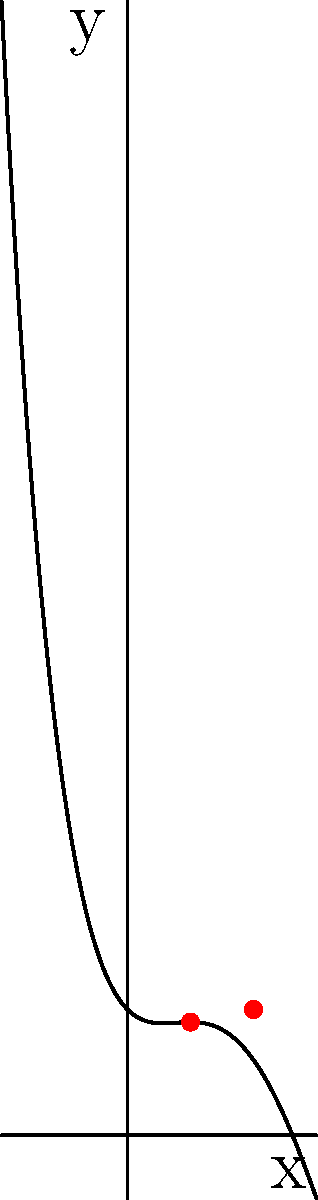The graph represents the audio wavelength of the theme song from a popular 80s variety show. If we model this wavelength as a polynomial function $f(x) = ax^4 + bx^3 + cx^2 + dx + e$, what is the degree of the polynomial, and how many local extrema does the function have in the visible interval? To answer this question, we need to analyze the graph:

1. Degree of the polynomial:
   - The graph appears to have one inflection point and changes direction multiple times.
   - The highest degree term dominates as x approaches infinity or negative infinity.
   - The curve seems to go up on both ends, indicating an even-degree polynomial.
   - Given the complexity of the curve, the degree is likely 4.

2. Local extrema:
   - Local extrema occur where the function changes from increasing to decreasing or vice versa.
   - Looking at the graph, we can see:
     a) A local maximum near x = 0
     b) A local minimum around x = 1
     c) Another local maximum around x = 2

   - The two red dots on the graph likely indicate two of these local extrema.

Therefore, the degree of the polynomial is 4, and there are 3 local extrema in the visible interval.
Answer: Degree: 4, Local extrema: 3 